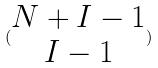<formula> <loc_0><loc_0><loc_500><loc_500>( \begin{matrix} N + I - 1 \\ I - 1 \end{matrix} )</formula> 